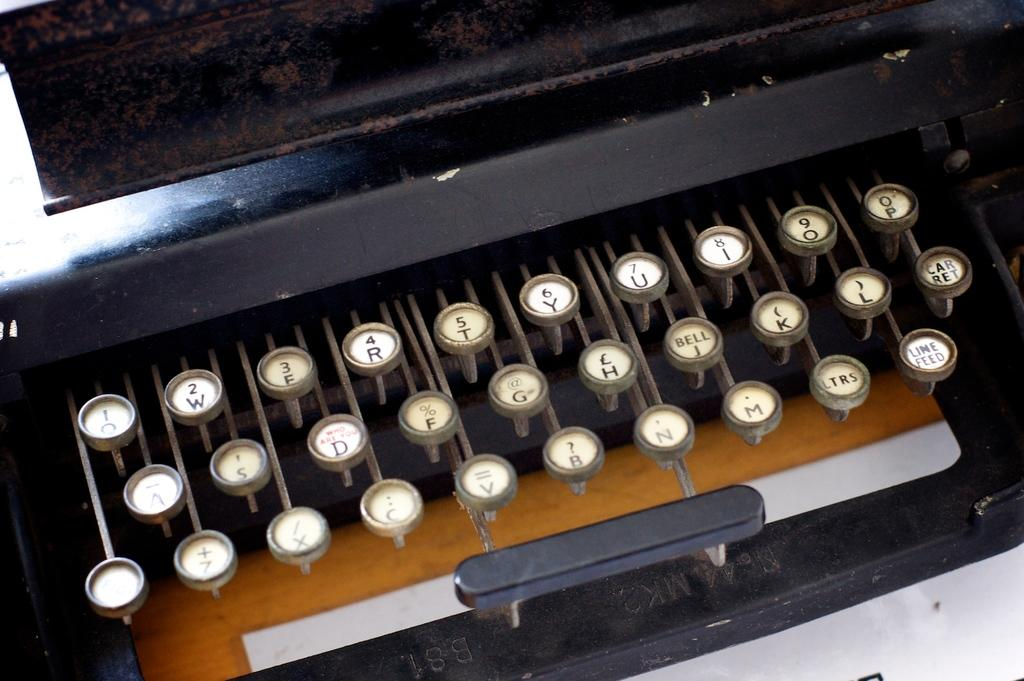<image>
Present a compact description of the photo's key features. the letter V is on the black and brown keyboard 